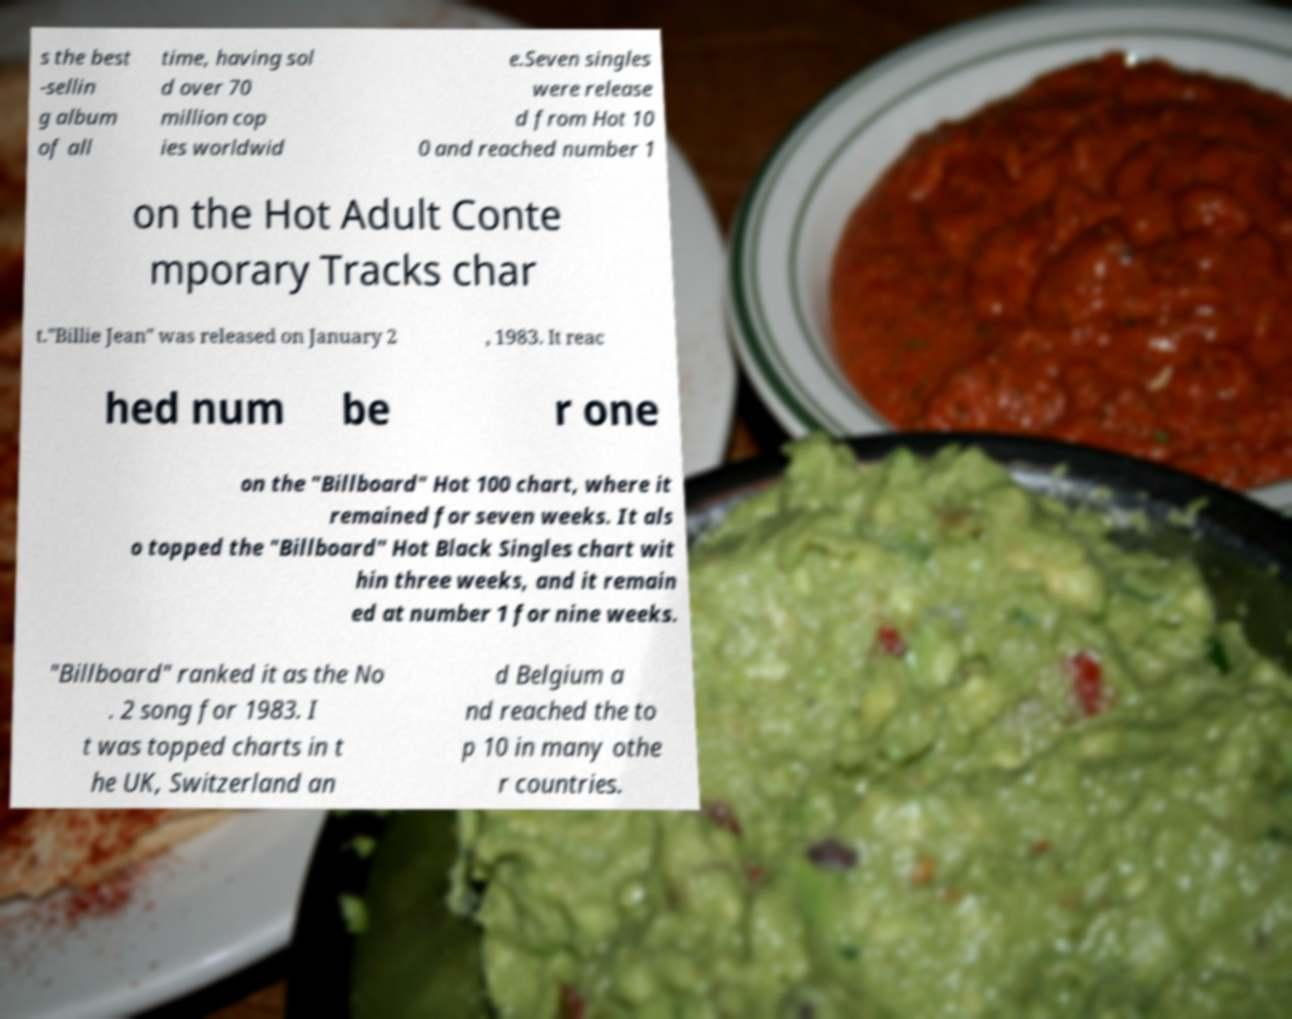Please identify and transcribe the text found in this image. s the best -sellin g album of all time, having sol d over 70 million cop ies worldwid e.Seven singles were release d from Hot 10 0 and reached number 1 on the Hot Adult Conte mporary Tracks char t."Billie Jean" was released on January 2 , 1983. It reac hed num be r one on the "Billboard" Hot 100 chart, where it remained for seven weeks. It als o topped the "Billboard" Hot Black Singles chart wit hin three weeks, and it remain ed at number 1 for nine weeks. "Billboard" ranked it as the No . 2 song for 1983. I t was topped charts in t he UK, Switzerland an d Belgium a nd reached the to p 10 in many othe r countries. 